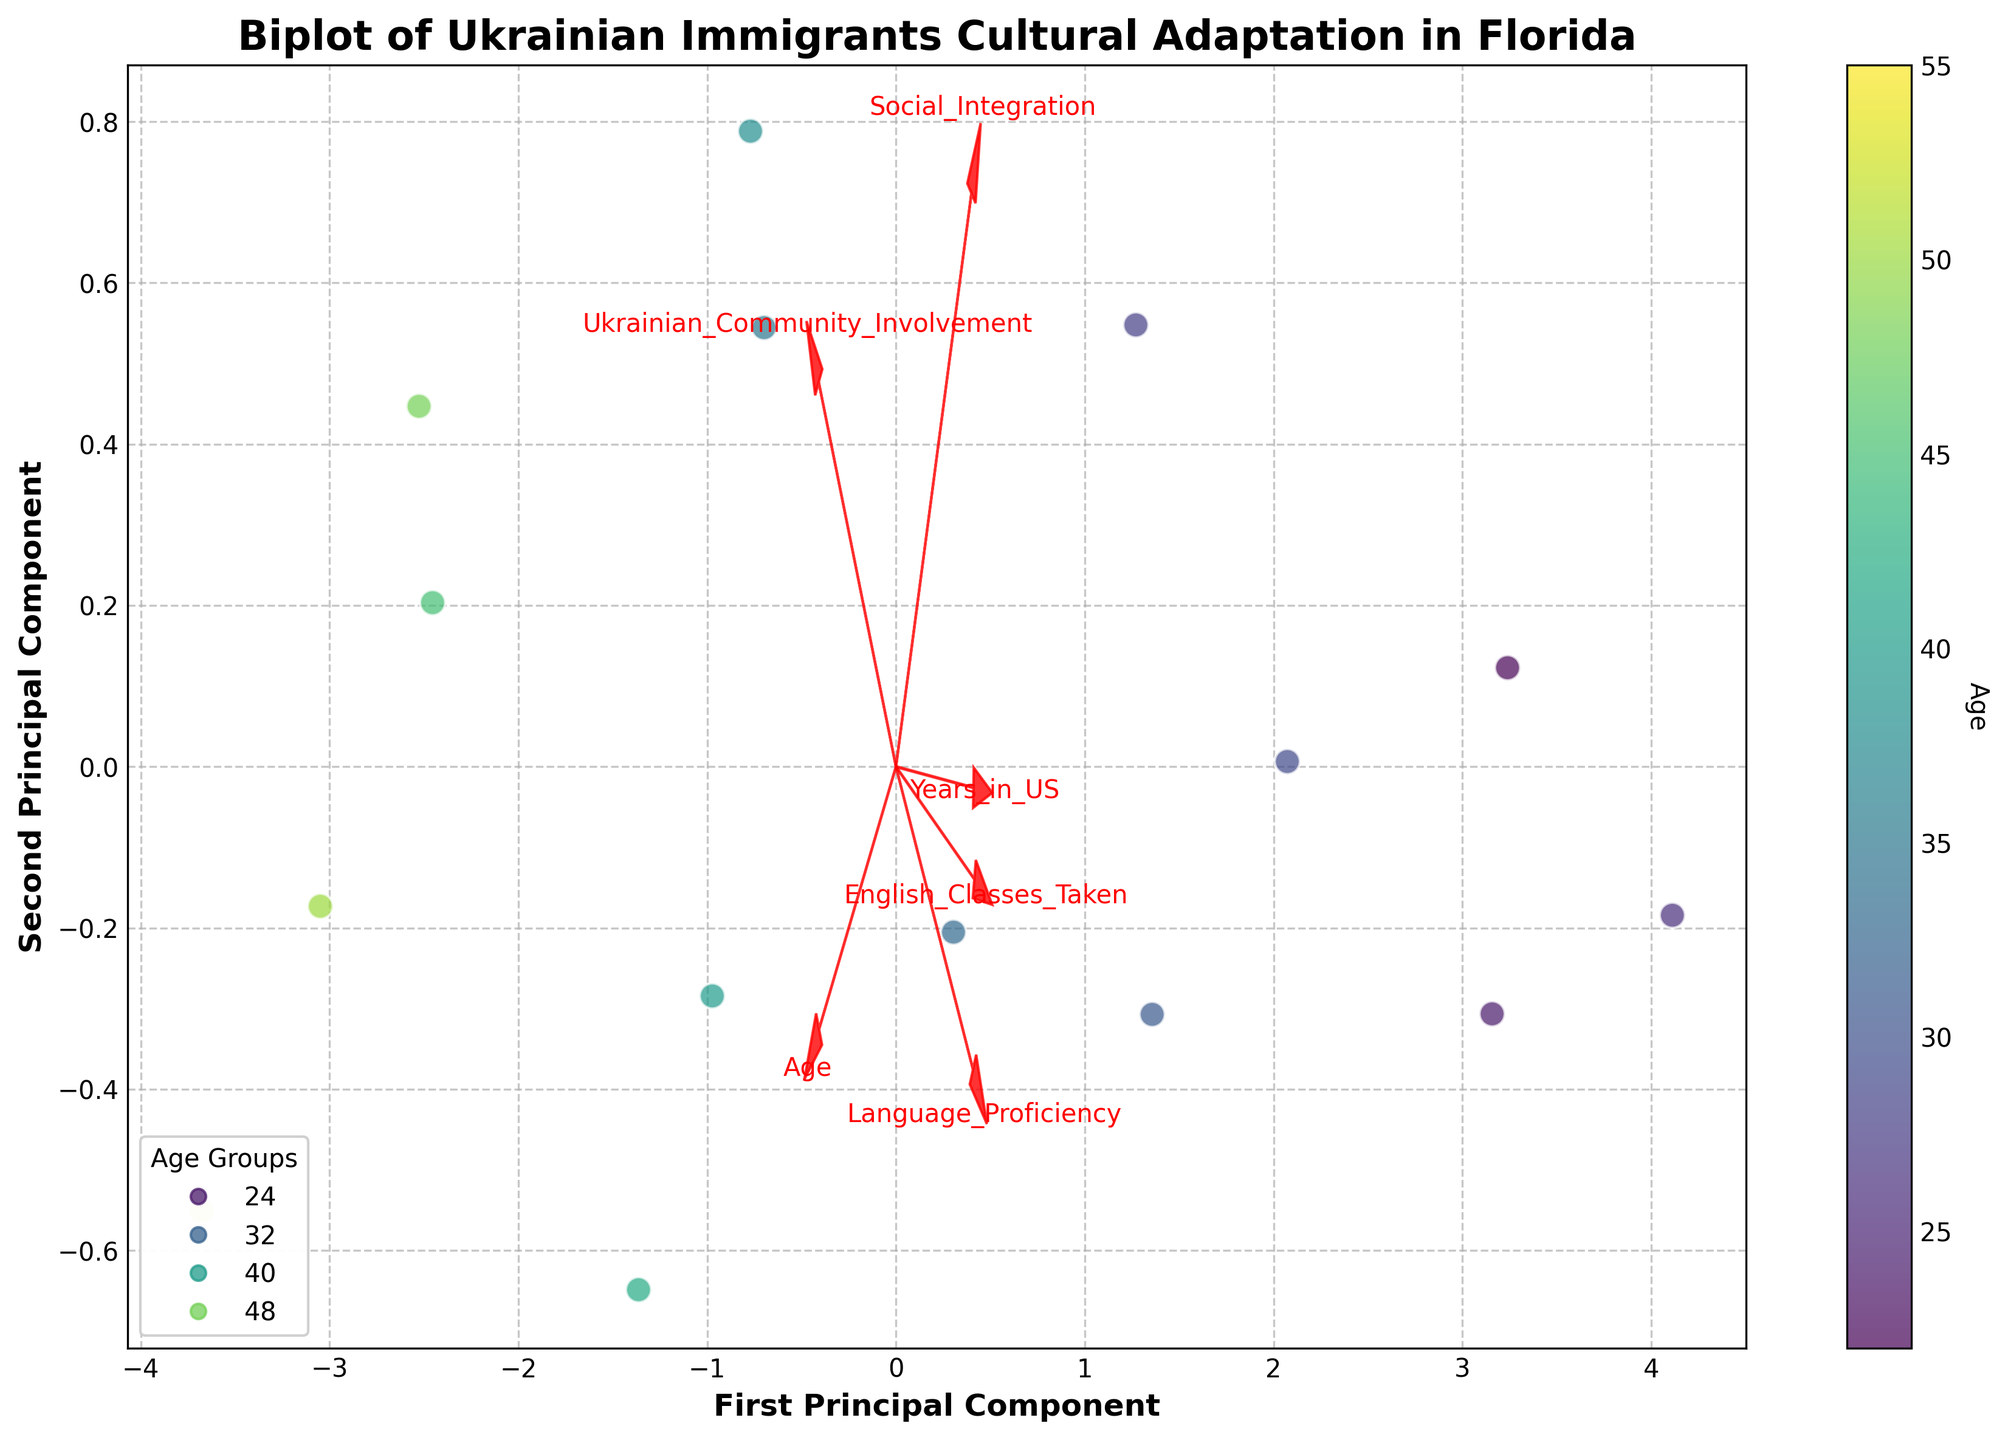How many data points are plotted on the biplot? The total number of data points corresponds to the number of rows in the dataset, which is 15. This can be visually confirmed by counting the number of plotted points.
Answer: 15 What does the color of the points represent? The color of the points represents 'Age,' as indicated by the color bar on the side of the plot.
Answer: Age What are the labels for the x-axis and y-axis in the biplot? The x-axis is labeled 'First Principal Component,' and the y-axis is labeled 'Second Principal Component,' which is clearly indicated on the axes in the figure.
Answer: First Principal Component, Second Principal Component Which feature has the highest loading on the first principal component? The feature with the highest loading on the first principal component can be determined by the arrow's length along the x-axis. The 'English_Classes_Taken' arrow is the longest in the positive x-direction, so it has the highest loading on the first principal component.
Answer: English_Classes_Taken What is the range of the 'Age' variable among the data points? The range of 'Age' can be determined by looking at the color bar and identifying the minimum and maximum values of the color scale. The color bar ranges from 22 to 55.
Answer: 22 to 55 Which combination of features is represented by the arrows that point in nearly opposite directions? Arrows that point in opposite directions indicate that the features are negatively correlated. 'Ukrainian_Community_Involvement' and 'English_Classes_Taken' arrows point in nearly opposite directions, suggesting a negative correlation.
Answer: Ukrainian_Community_Involvement, English_Classes_Taken How is 'Years_in_US' generally related to 'Language_Proficiency' based on their respective arrows? The 'Years_in_US' and 'Language_Proficiency' arrows both point in the same general direction, suggesting that these two features are positively correlated.
Answer: Positively correlated Which feature is least correlated with 'Age' based on the arrows in the biplot? The feature whose arrow is almost perpendicular to the 'Age' arrow has the least correlation with it. 'English_Classes_Taken' appears to be the least correlated with 'Age' as their arrows are nearly perpendicular.
Answer: English_Classes_Taken What can be inferred about the relationship between 'Social_Integration' and 'Language_Proficiency'? The arrows for 'Social_Integration' and 'Language_Proficiency' point in similar directions, indicating that these two features are positively correlated.
Answer: Positively correlated 